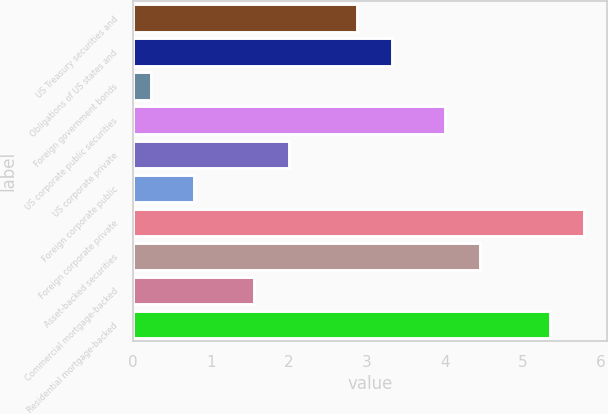Convert chart. <chart><loc_0><loc_0><loc_500><loc_500><bar_chart><fcel>US Treasury securities and<fcel>Obligations of US states and<fcel>Foreign government bonds<fcel>US corporate public securities<fcel>US corporate private<fcel>Foreign corporate public<fcel>Foreign corporate private<fcel>Asset-backed securities<fcel>Commercial mortgage-backed<fcel>Residential mortgage-backed<nl><fcel>2.88<fcel>3.32<fcel>0.23<fcel>4<fcel>2<fcel>0.78<fcel>5.79<fcel>4.45<fcel>1.56<fcel>5.35<nl></chart> 